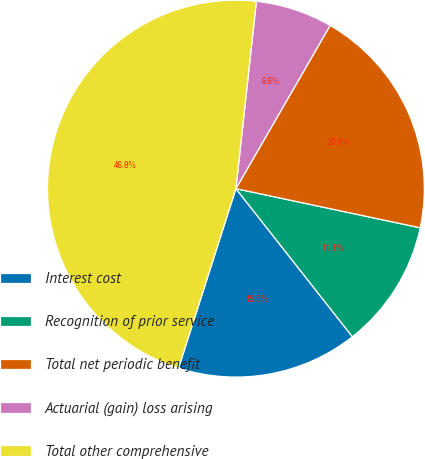<chart> <loc_0><loc_0><loc_500><loc_500><pie_chart><fcel>Interest cost<fcel>Recognition of prior service<fcel>Total net periodic benefit<fcel>Actuarial (gain) loss arising<fcel>Total other comprehensive<nl><fcel>15.53%<fcel>11.06%<fcel>20.0%<fcel>6.6%<fcel>46.81%<nl></chart> 